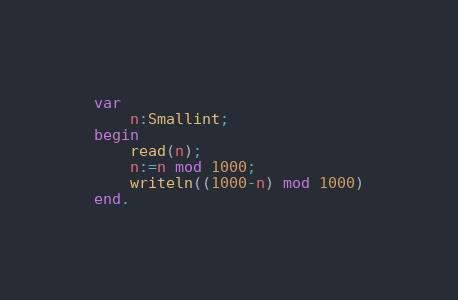<code> <loc_0><loc_0><loc_500><loc_500><_Pascal_>var
	n:Smallint;
begin
    read(n);
    n:=n mod 1000;
    writeln((1000-n) mod 1000)
end.</code> 